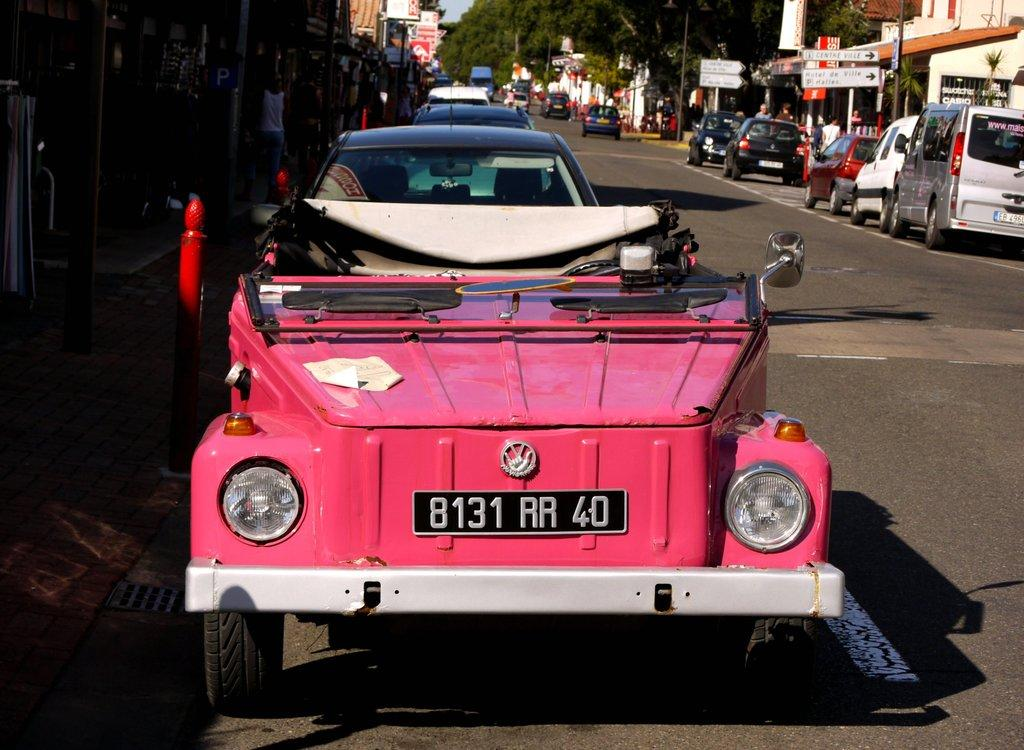What is happening on the road in the image? There are vehicles on the road in the image. What can be seen in the background of the image? Trees, buildings, and poles are visible at the top of the image. How many trails can be seen in the image? A: There are no trails visible in the image. 